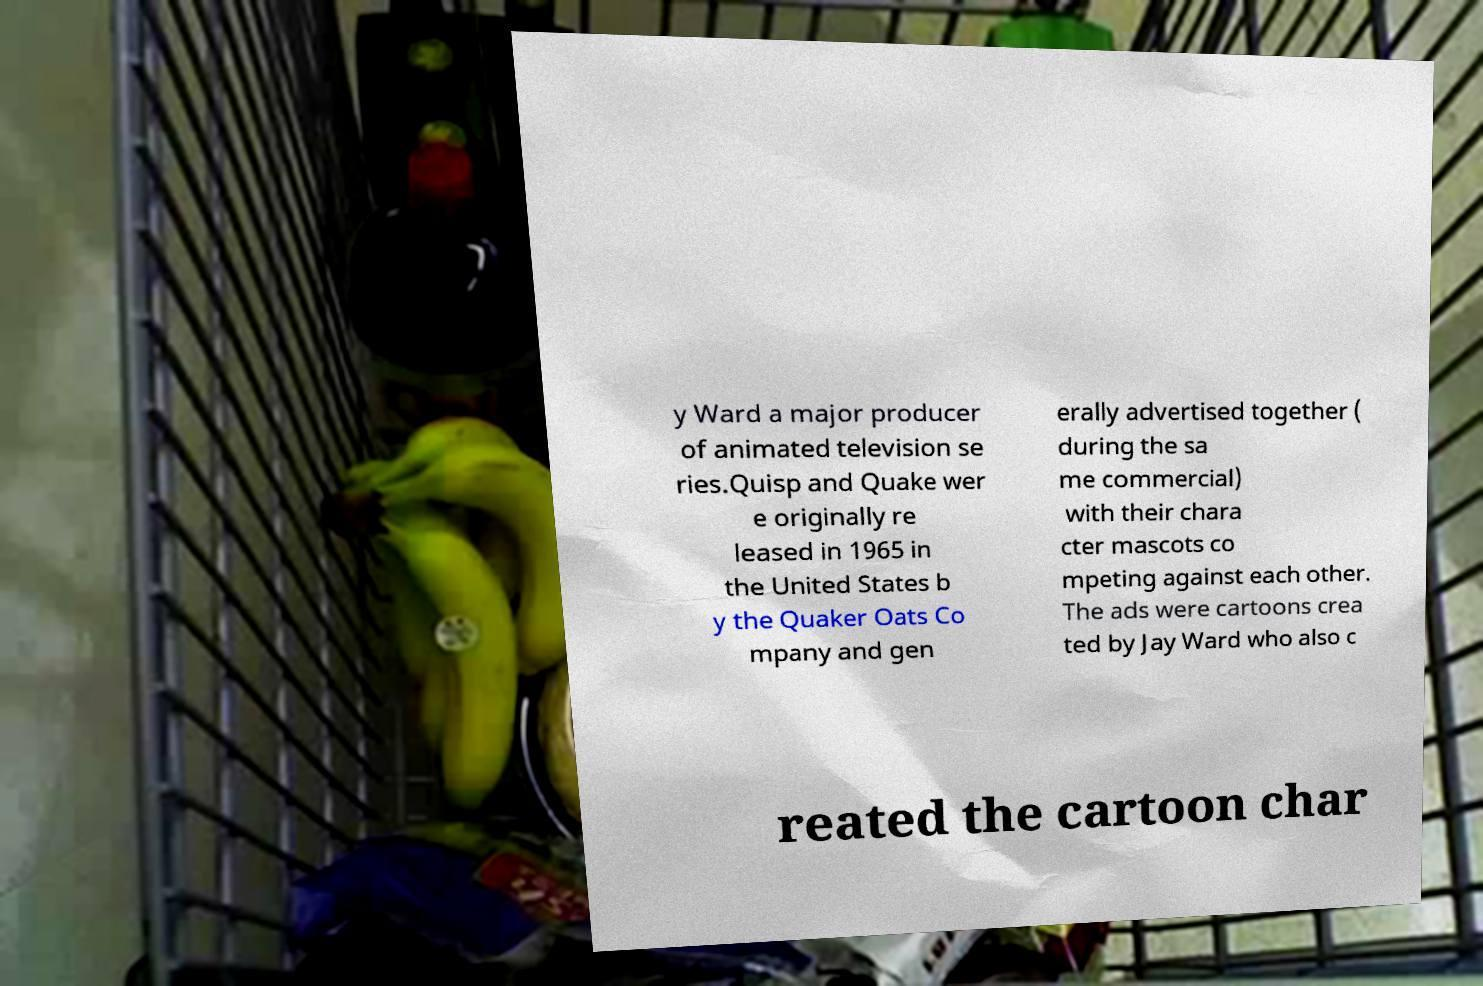Please read and relay the text visible in this image. What does it say? y Ward a major producer of animated television se ries.Quisp and Quake wer e originally re leased in 1965 in the United States b y the Quaker Oats Co mpany and gen erally advertised together ( during the sa me commercial) with their chara cter mascots co mpeting against each other. The ads were cartoons crea ted by Jay Ward who also c reated the cartoon char 